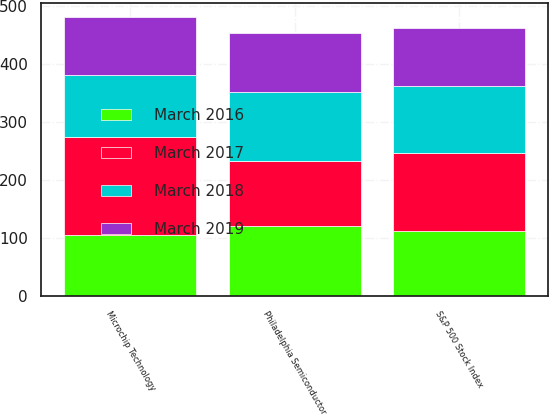Convert chart to OTSL. <chart><loc_0><loc_0><loc_500><loc_500><stacked_bar_chart><ecel><fcel>Microchip Technology<fcel>S&P 500 Stock Index<fcel>Philadelphia Semiconductor<nl><fcel>March 2019<fcel>100<fcel>100<fcel>100<nl><fcel>March 2016<fcel>105.55<fcel>112.73<fcel>120.57<nl><fcel>March 2018<fcel>107.37<fcel>114.74<fcel>119.69<nl><fcel>March 2017<fcel>168.33<fcel>134.45<fcel>112.73<nl></chart> 